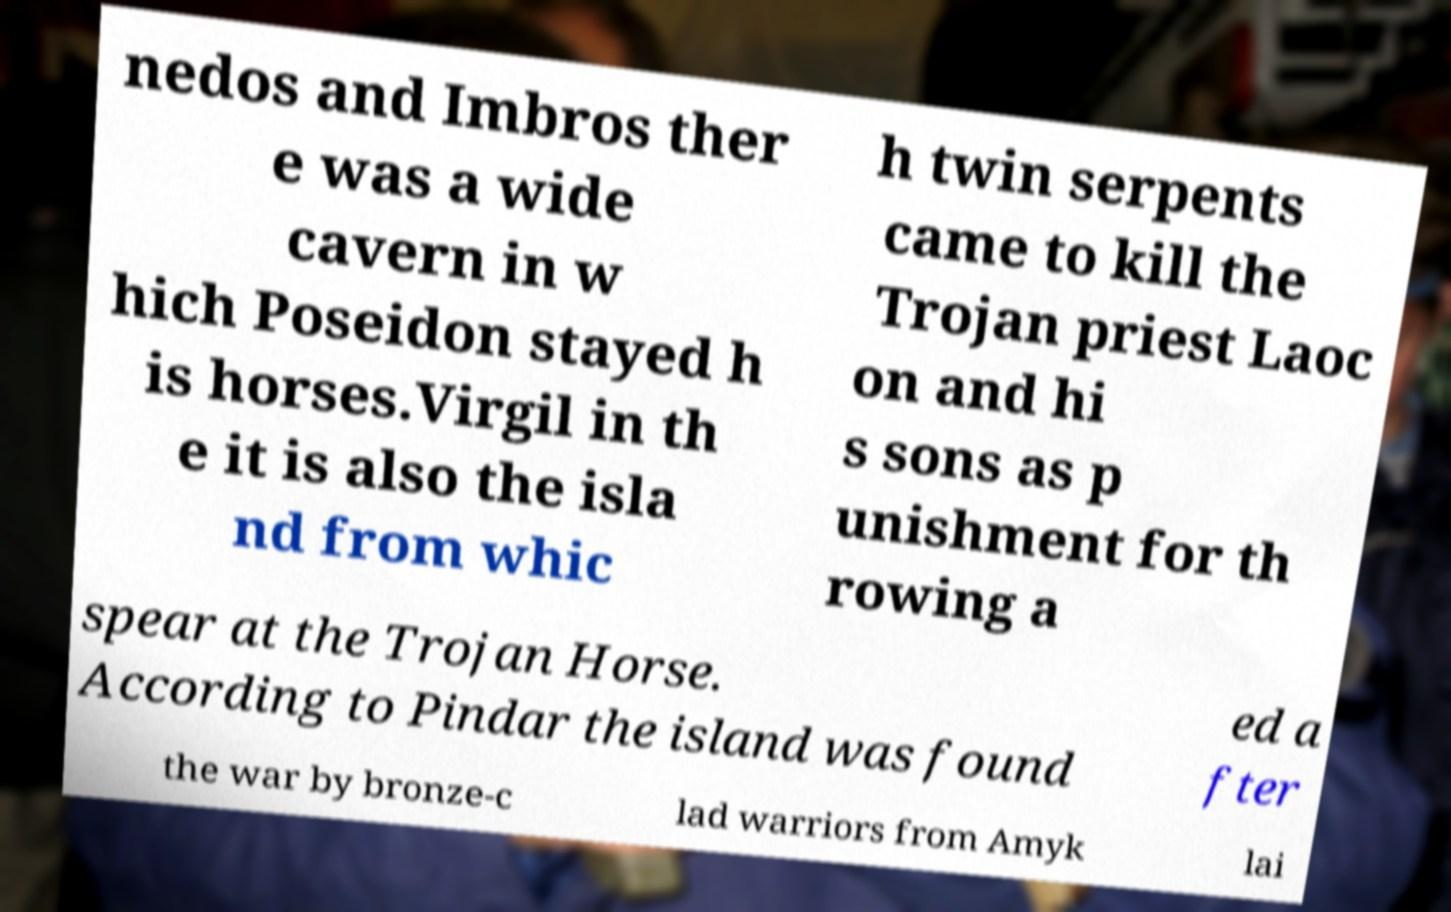Could you assist in decoding the text presented in this image and type it out clearly? nedos and Imbros ther e was a wide cavern in w hich Poseidon stayed h is horses.Virgil in th e it is also the isla nd from whic h twin serpents came to kill the Trojan priest Laoc on and hi s sons as p unishment for th rowing a spear at the Trojan Horse. According to Pindar the island was found ed a fter the war by bronze-c lad warriors from Amyk lai 